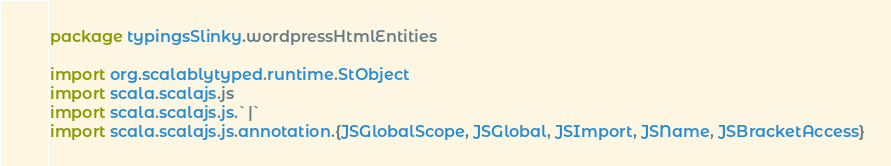<code> <loc_0><loc_0><loc_500><loc_500><_Scala_>package typingsSlinky.wordpressHtmlEntities

import org.scalablytyped.runtime.StObject
import scala.scalajs.js
import scala.scalajs.js.`|`
import scala.scalajs.js.annotation.{JSGlobalScope, JSGlobal, JSImport, JSName, JSBracketAccess}
</code> 